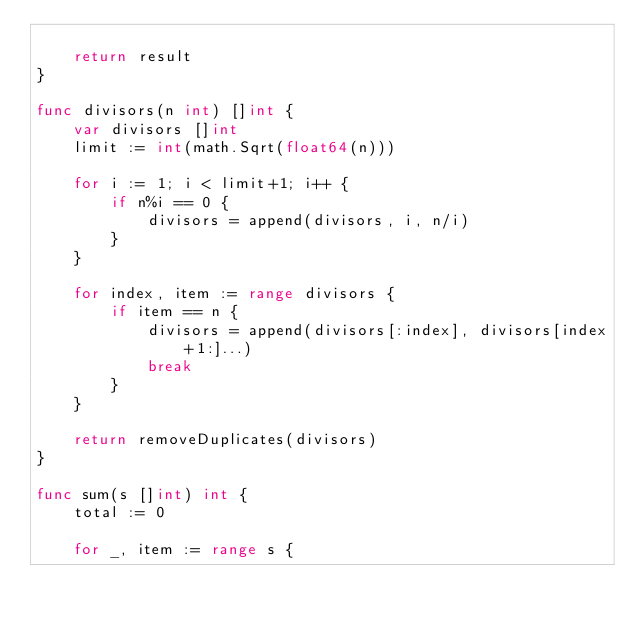Convert code to text. <code><loc_0><loc_0><loc_500><loc_500><_Go_>
	return result
}

func divisors(n int) []int {
	var divisors []int
	limit := int(math.Sqrt(float64(n)))

	for i := 1; i < limit+1; i++ {
		if n%i == 0 {
			divisors = append(divisors, i, n/i)
		}
	}

	for index, item := range divisors {
		if item == n {
			divisors = append(divisors[:index], divisors[index+1:]...)
			break
		}
	}

	return removeDuplicates(divisors)
}

func sum(s []int) int {
	total := 0

	for _, item := range s {</code> 